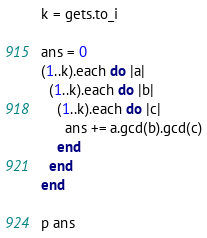<code> <loc_0><loc_0><loc_500><loc_500><_Ruby_>k = gets.to_i

ans = 0
(1..k).each do |a|
  (1..k).each do |b|
    (1..k).each do |c|
      ans += a.gcd(b).gcd(c)
    end
  end
end

p ans</code> 